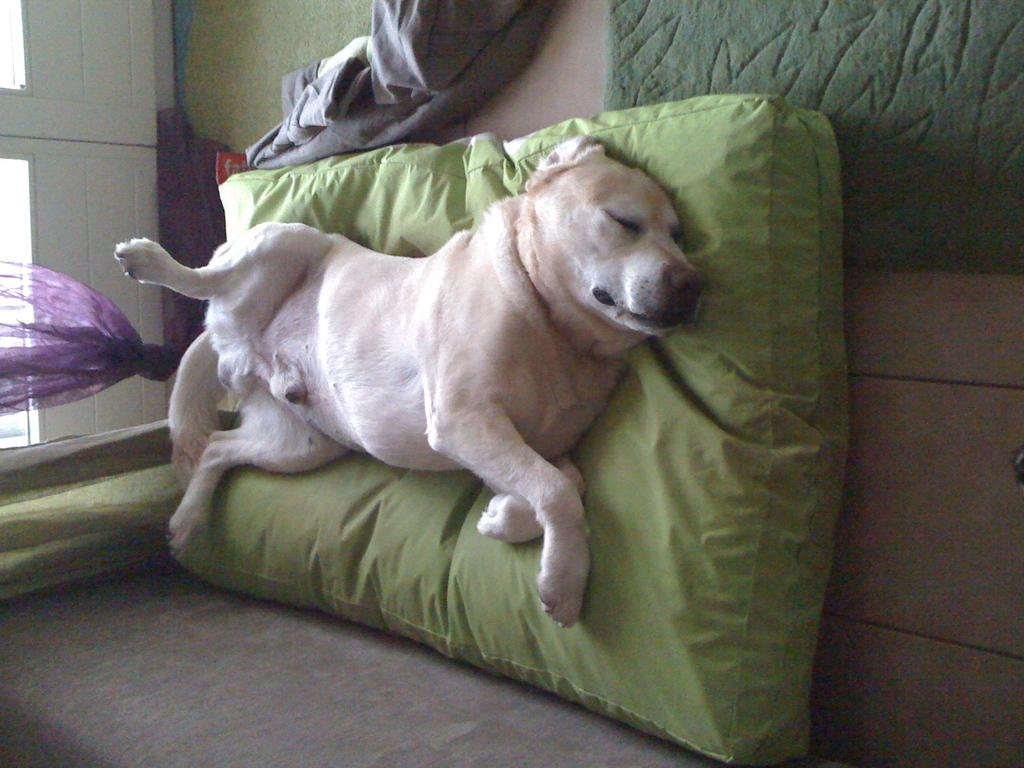What type of animal is in the image? There is a dog in the image. Where is the dog located? The dog is laying on the bed. What is covering part of the bed in the image? There is a blanket in the image. What type of window treatment is visible in the image? There are curtains in the image. What type of religion is being practiced in the image? There is no indication of any religious practice in the image; it features a dog laying on a bed with a blanket and curtains. What type of tin object can be seen in the image? There is no tin object present in the image. 